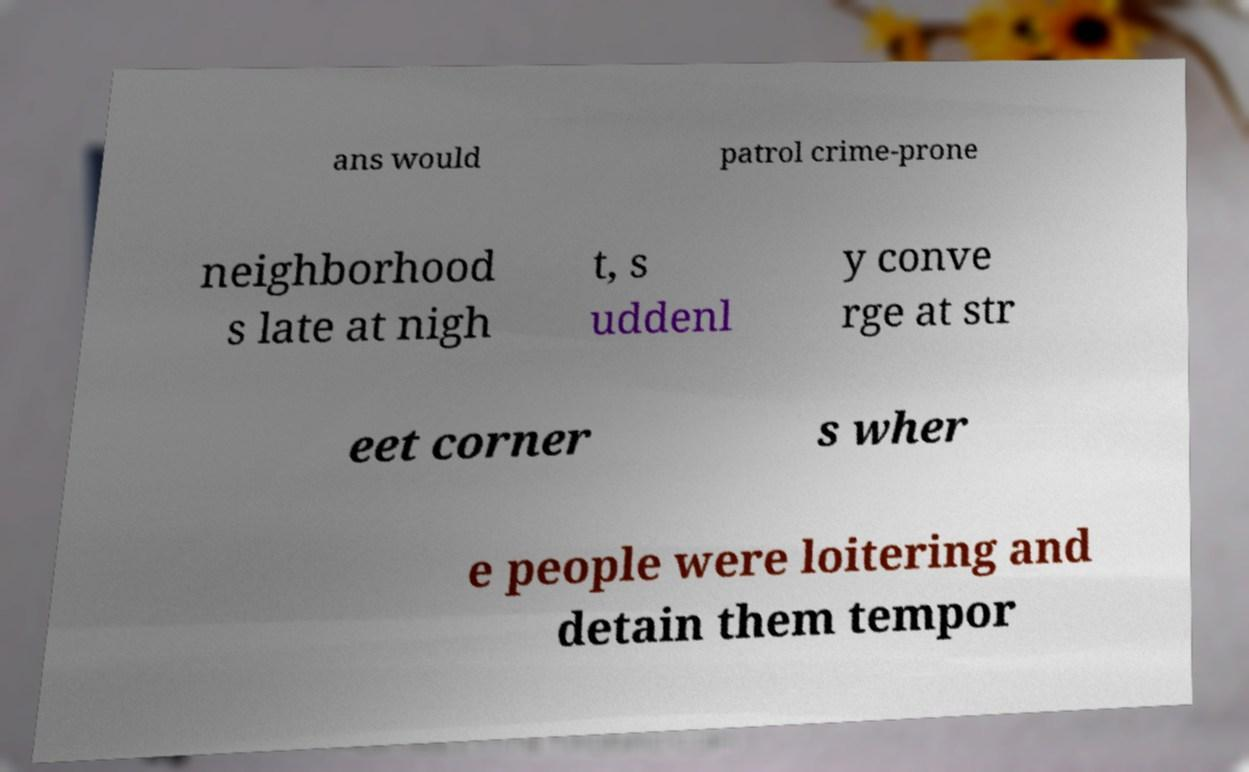There's text embedded in this image that I need extracted. Can you transcribe it verbatim? ans would patrol crime-prone neighborhood s late at nigh t, s uddenl y conve rge at str eet corner s wher e people were loitering and detain them tempor 